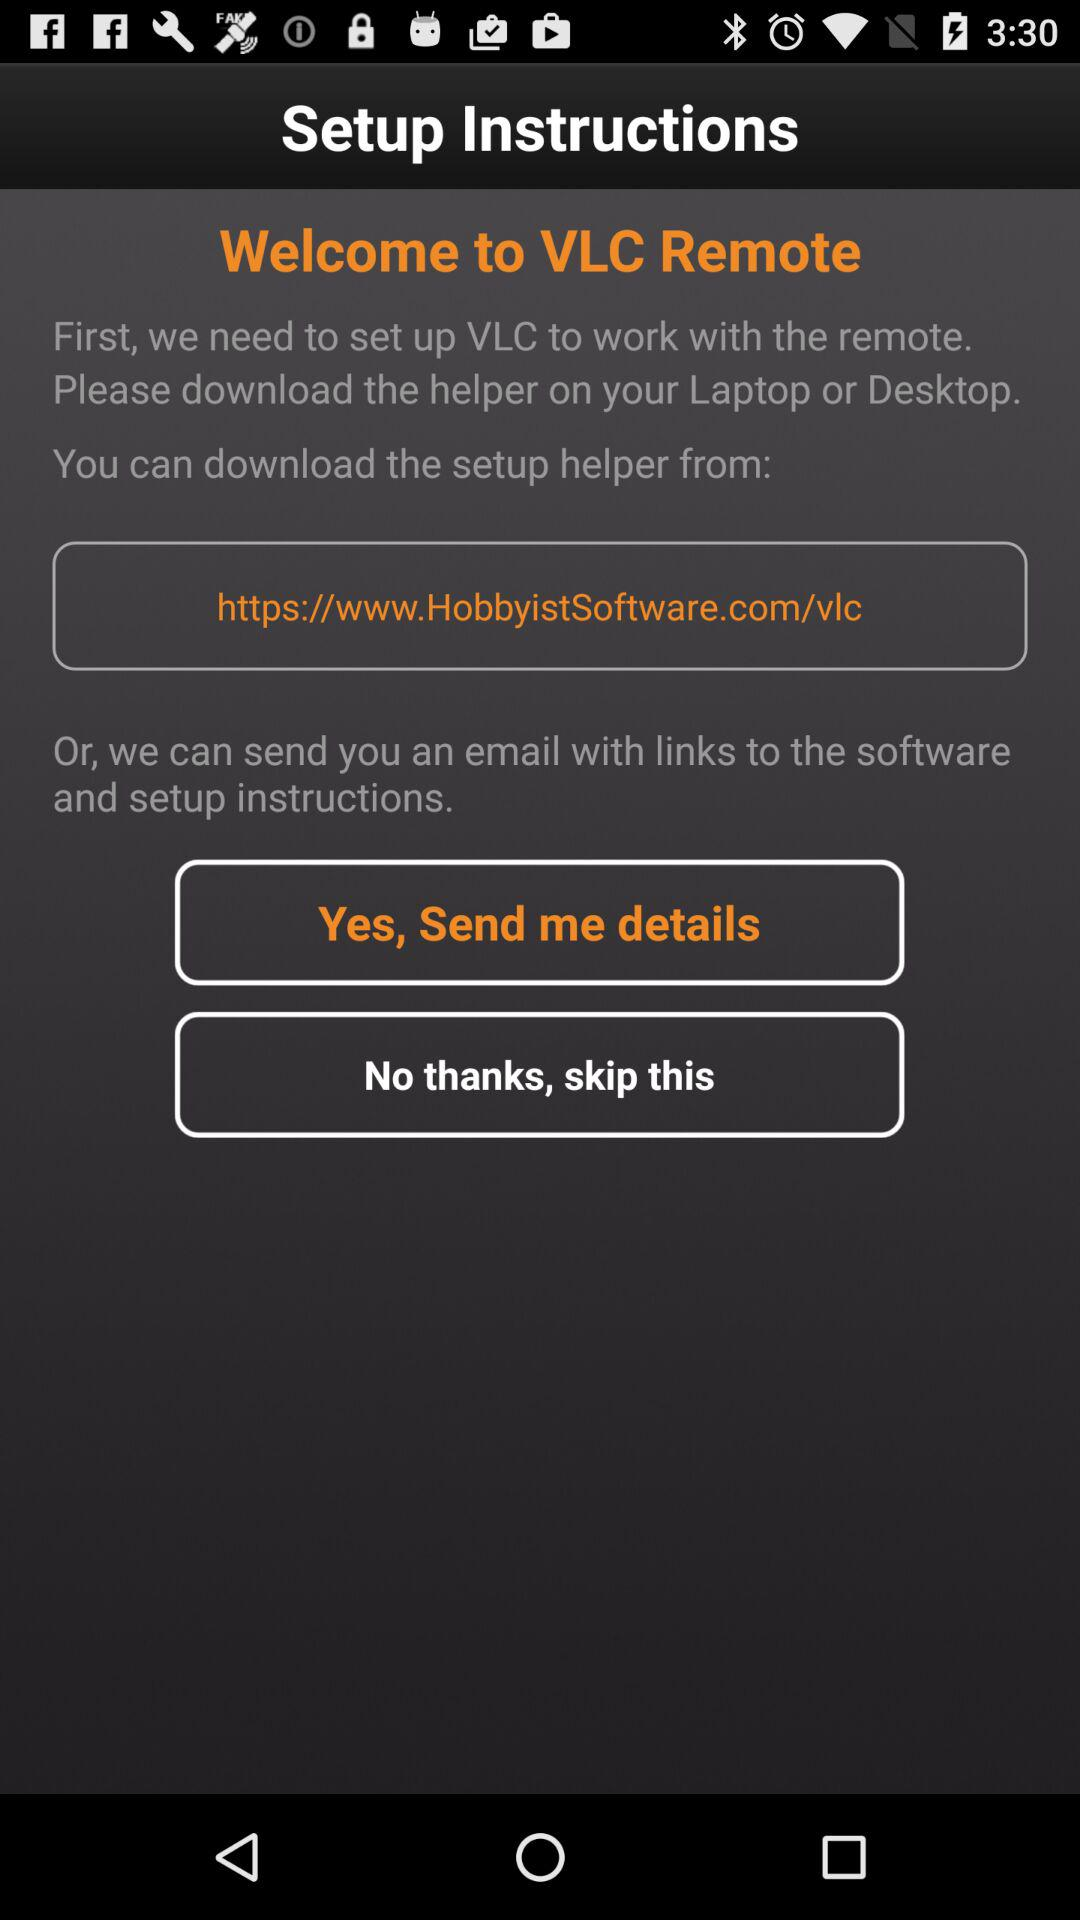Where are the links and setup instructions sent? The links and setup instructions were sent to your email. 